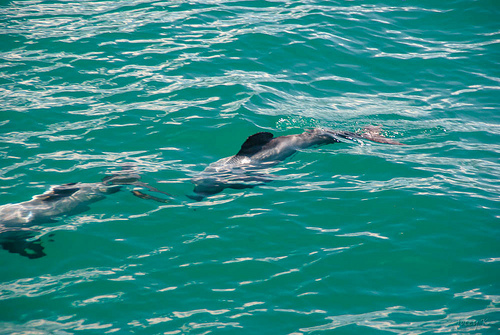<image>
Can you confirm if the fish is above the water? No. The fish is not positioned above the water. The vertical arrangement shows a different relationship. 